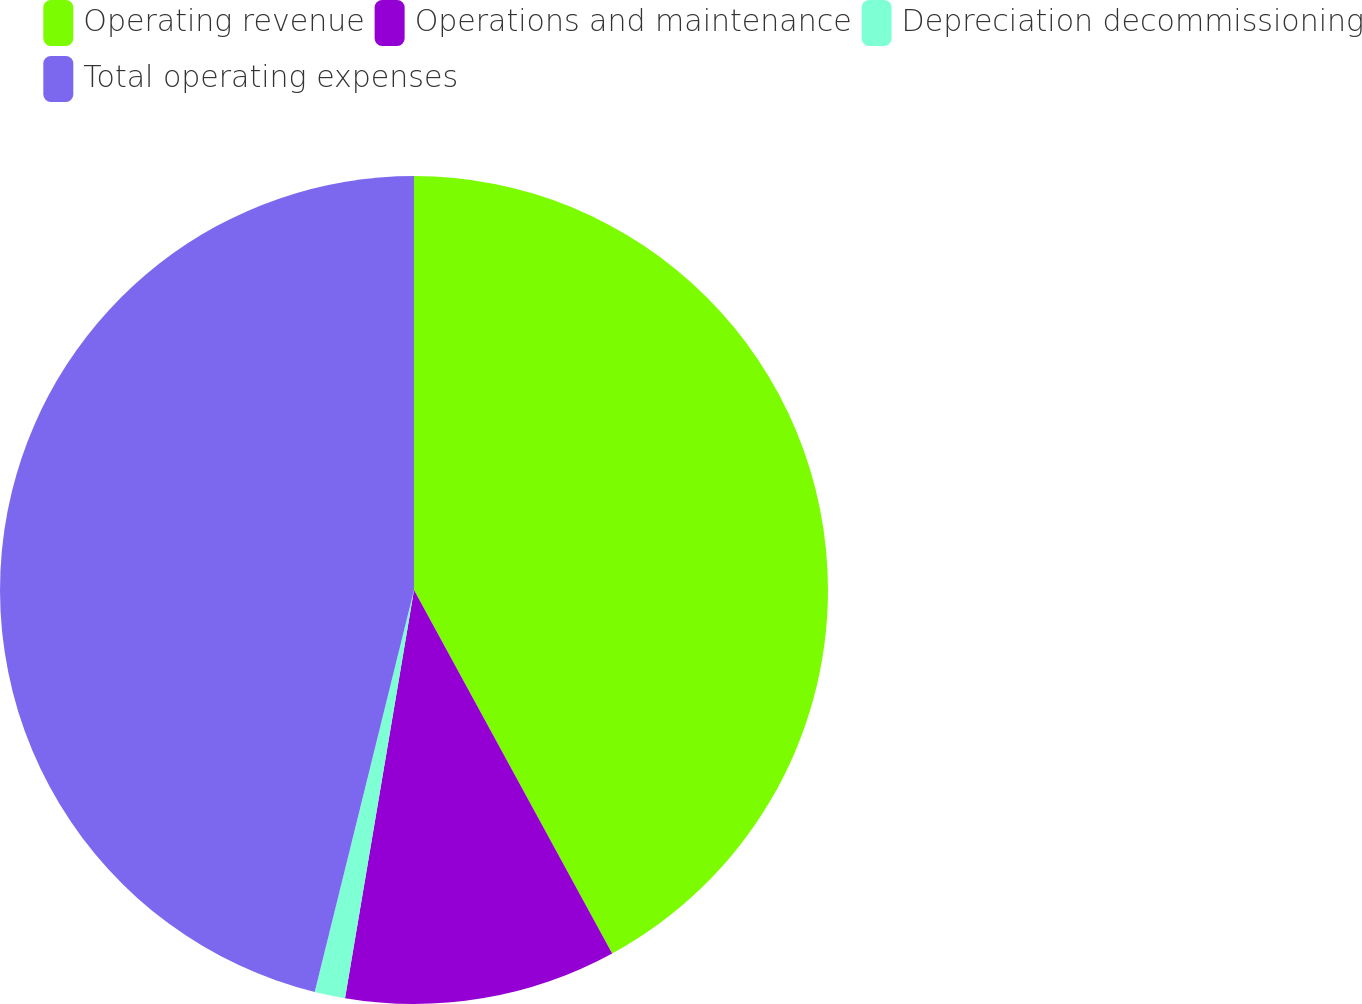Convert chart to OTSL. <chart><loc_0><loc_0><loc_500><loc_500><pie_chart><fcel>Operating revenue<fcel>Operations and maintenance<fcel>Depreciation decommissioning<fcel>Total operating expenses<nl><fcel>42.06%<fcel>10.61%<fcel>1.19%<fcel>46.15%<nl></chart> 